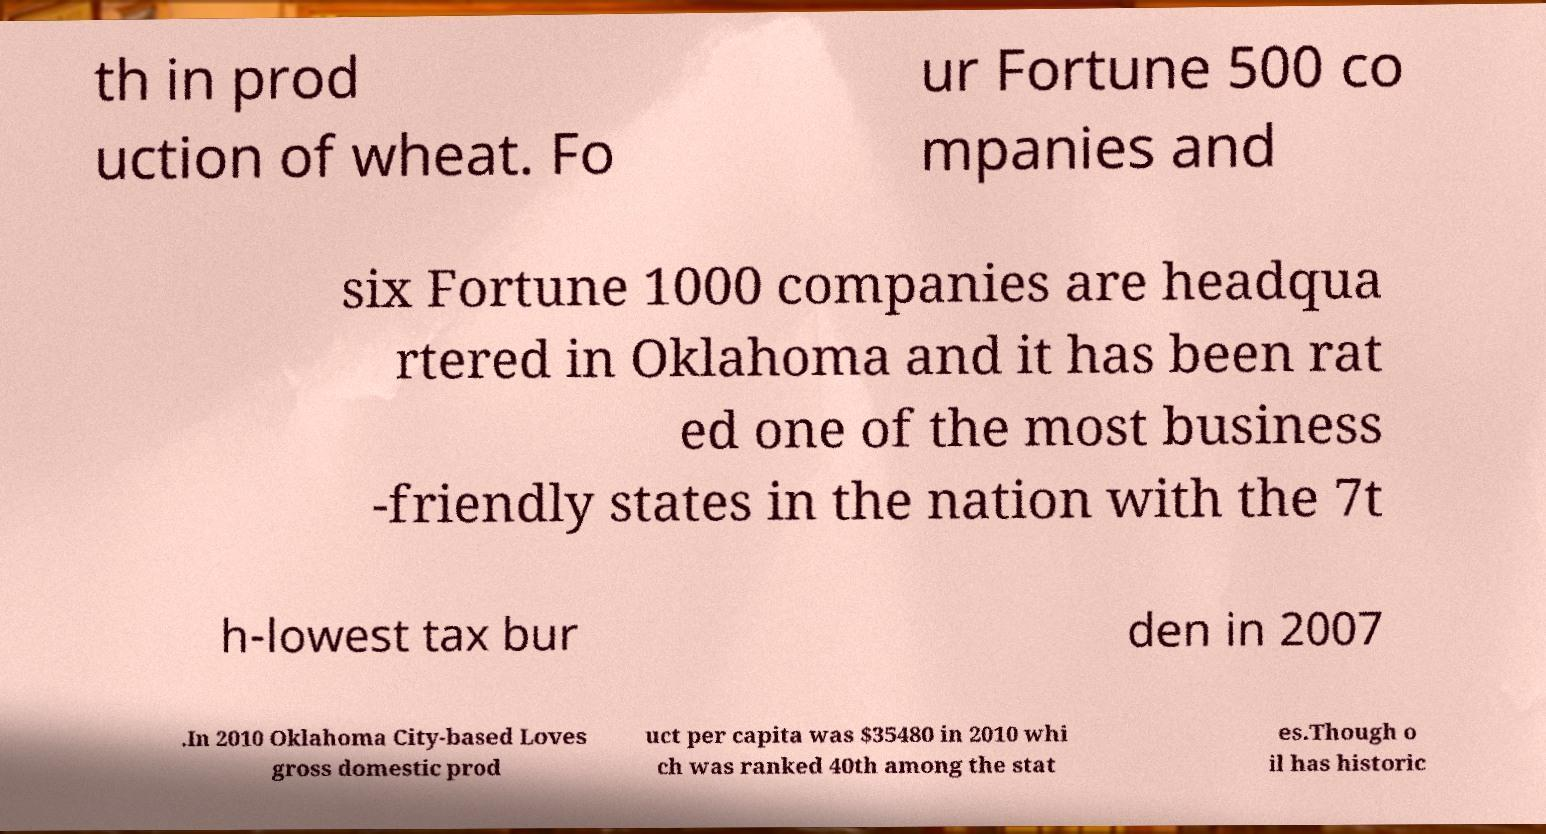Please read and relay the text visible in this image. What does it say? th in prod uction of wheat. Fo ur Fortune 500 co mpanies and six Fortune 1000 companies are headqua rtered in Oklahoma and it has been rat ed one of the most business -friendly states in the nation with the 7t h-lowest tax bur den in 2007 .In 2010 Oklahoma City-based Loves gross domestic prod uct per capita was $35480 in 2010 whi ch was ranked 40th among the stat es.Though o il has historic 